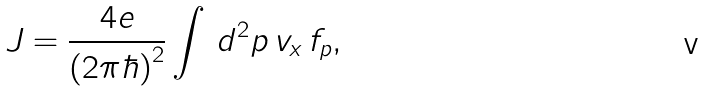<formula> <loc_0><loc_0><loc_500><loc_500>J = \frac { 4 e } { ( 2 \pi \hbar { ) } ^ { 2 } } \int \, d ^ { 2 } { p } \, v _ { x } \, f _ { p } ,</formula> 